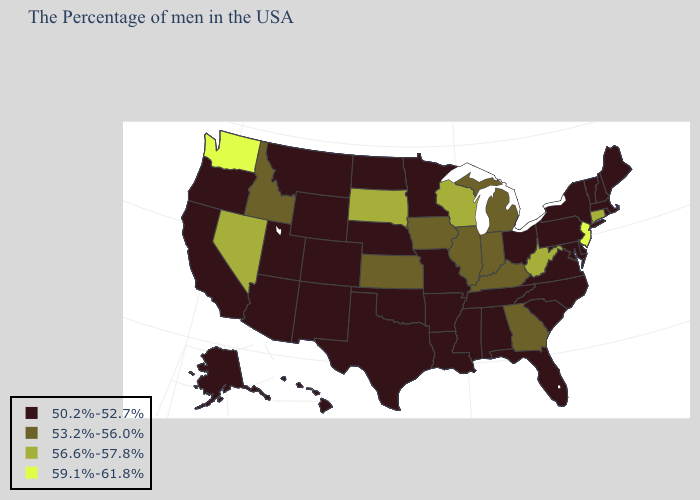How many symbols are there in the legend?
Be succinct. 4. What is the value of Indiana?
Give a very brief answer. 53.2%-56.0%. Name the states that have a value in the range 50.2%-52.7%?
Concise answer only. Maine, Massachusetts, Rhode Island, New Hampshire, Vermont, New York, Delaware, Maryland, Pennsylvania, Virginia, North Carolina, South Carolina, Ohio, Florida, Alabama, Tennessee, Mississippi, Louisiana, Missouri, Arkansas, Minnesota, Nebraska, Oklahoma, Texas, North Dakota, Wyoming, Colorado, New Mexico, Utah, Montana, Arizona, California, Oregon, Alaska, Hawaii. Does the map have missing data?
Concise answer only. No. Which states hav the highest value in the Northeast?
Concise answer only. New Jersey. What is the highest value in states that border Florida?
Keep it brief. 53.2%-56.0%. What is the lowest value in the West?
Write a very short answer. 50.2%-52.7%. What is the lowest value in the MidWest?
Be succinct. 50.2%-52.7%. Name the states that have a value in the range 53.2%-56.0%?
Keep it brief. Georgia, Michigan, Kentucky, Indiana, Illinois, Iowa, Kansas, Idaho. What is the value of Alaska?
Quick response, please. 50.2%-52.7%. Name the states that have a value in the range 53.2%-56.0%?
Give a very brief answer. Georgia, Michigan, Kentucky, Indiana, Illinois, Iowa, Kansas, Idaho. What is the value of Mississippi?
Be succinct. 50.2%-52.7%. How many symbols are there in the legend?
Be succinct. 4. Does Wyoming have the lowest value in the West?
Keep it brief. Yes. 